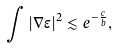Convert formula to latex. <formula><loc_0><loc_0><loc_500><loc_500>\int | \nabla \epsilon | ^ { 2 } \lesssim e ^ { - \frac { c } { b } } ,</formula> 